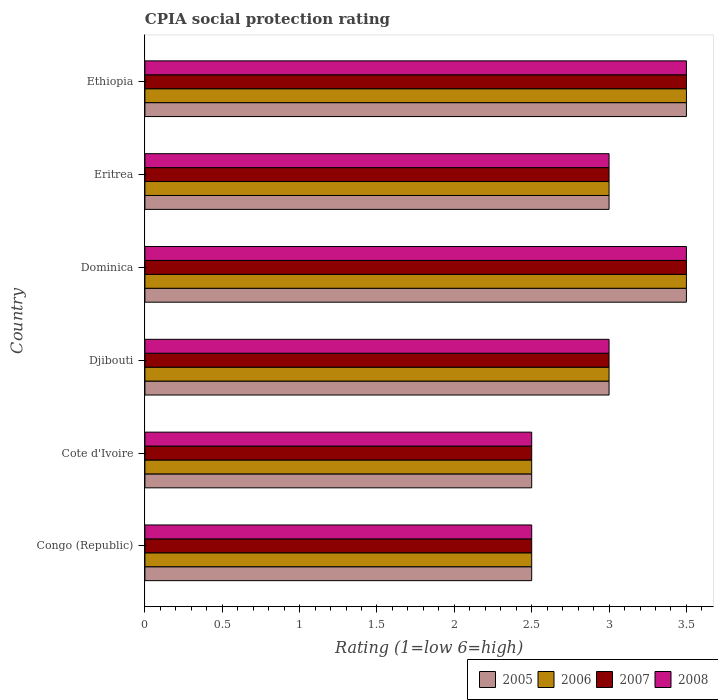How many groups of bars are there?
Your answer should be very brief. 6. How many bars are there on the 6th tick from the top?
Give a very brief answer. 4. What is the label of the 4th group of bars from the top?
Provide a succinct answer. Djibouti. In how many cases, is the number of bars for a given country not equal to the number of legend labels?
Provide a succinct answer. 0. What is the CPIA rating in 2005 in Congo (Republic)?
Make the answer very short. 2.5. Across all countries, what is the maximum CPIA rating in 2007?
Offer a terse response. 3.5. Across all countries, what is the minimum CPIA rating in 2006?
Offer a terse response. 2.5. In which country was the CPIA rating in 2007 maximum?
Ensure brevity in your answer.  Dominica. In which country was the CPIA rating in 2006 minimum?
Your answer should be very brief. Congo (Republic). What is the total CPIA rating in 2005 in the graph?
Provide a succinct answer. 18. What is the difference between the CPIA rating in 2007 in Cote d'Ivoire and that in Ethiopia?
Offer a very short reply. -1. In how many countries, is the CPIA rating in 2006 greater than 0.6 ?
Provide a succinct answer. 6. What is the ratio of the CPIA rating in 2005 in Congo (Republic) to that in Ethiopia?
Keep it short and to the point. 0.71. Is the CPIA rating in 2008 in Eritrea less than that in Ethiopia?
Your answer should be very brief. Yes. What is the difference between the highest and the second highest CPIA rating in 2005?
Ensure brevity in your answer.  0. What does the 4th bar from the top in Congo (Republic) represents?
Your response must be concise. 2005. Is it the case that in every country, the sum of the CPIA rating in 2008 and CPIA rating in 2005 is greater than the CPIA rating in 2007?
Your answer should be compact. Yes. How many bars are there?
Your answer should be very brief. 24. Are all the bars in the graph horizontal?
Your response must be concise. Yes. What is the difference between two consecutive major ticks on the X-axis?
Keep it short and to the point. 0.5. How many legend labels are there?
Your response must be concise. 4. How are the legend labels stacked?
Offer a very short reply. Horizontal. What is the title of the graph?
Provide a short and direct response. CPIA social protection rating. What is the Rating (1=low 6=high) of 2005 in Congo (Republic)?
Your answer should be very brief. 2.5. What is the Rating (1=low 6=high) in 2007 in Congo (Republic)?
Provide a short and direct response. 2.5. What is the Rating (1=low 6=high) in 2008 in Congo (Republic)?
Provide a short and direct response. 2.5. What is the Rating (1=low 6=high) of 2005 in Cote d'Ivoire?
Offer a very short reply. 2.5. What is the Rating (1=low 6=high) in 2008 in Cote d'Ivoire?
Ensure brevity in your answer.  2.5. What is the Rating (1=low 6=high) in 2006 in Djibouti?
Ensure brevity in your answer.  3. What is the Rating (1=low 6=high) in 2007 in Djibouti?
Make the answer very short. 3. What is the Rating (1=low 6=high) in 2006 in Dominica?
Offer a terse response. 3.5. What is the Rating (1=low 6=high) of 2007 in Dominica?
Make the answer very short. 3.5. What is the Rating (1=low 6=high) in 2008 in Dominica?
Your answer should be compact. 3.5. What is the Rating (1=low 6=high) in 2007 in Eritrea?
Provide a succinct answer. 3. What is the Rating (1=low 6=high) in 2006 in Ethiopia?
Ensure brevity in your answer.  3.5. What is the Rating (1=low 6=high) in 2008 in Ethiopia?
Provide a succinct answer. 3.5. Across all countries, what is the maximum Rating (1=low 6=high) of 2005?
Give a very brief answer. 3.5. Across all countries, what is the maximum Rating (1=low 6=high) in 2008?
Make the answer very short. 3.5. Across all countries, what is the minimum Rating (1=low 6=high) in 2006?
Provide a succinct answer. 2.5. What is the total Rating (1=low 6=high) of 2005 in the graph?
Keep it short and to the point. 18. What is the total Rating (1=low 6=high) of 2007 in the graph?
Your answer should be very brief. 18. What is the total Rating (1=low 6=high) in 2008 in the graph?
Make the answer very short. 18. What is the difference between the Rating (1=low 6=high) in 2005 in Congo (Republic) and that in Cote d'Ivoire?
Ensure brevity in your answer.  0. What is the difference between the Rating (1=low 6=high) in 2007 in Congo (Republic) and that in Djibouti?
Give a very brief answer. -0.5. What is the difference between the Rating (1=low 6=high) of 2008 in Congo (Republic) and that in Djibouti?
Keep it short and to the point. -0.5. What is the difference between the Rating (1=low 6=high) in 2005 in Congo (Republic) and that in Dominica?
Your answer should be very brief. -1. What is the difference between the Rating (1=low 6=high) in 2007 in Congo (Republic) and that in Dominica?
Ensure brevity in your answer.  -1. What is the difference between the Rating (1=low 6=high) of 2008 in Congo (Republic) and that in Eritrea?
Give a very brief answer. -0.5. What is the difference between the Rating (1=low 6=high) of 2005 in Congo (Republic) and that in Ethiopia?
Provide a succinct answer. -1. What is the difference between the Rating (1=low 6=high) of 2006 in Congo (Republic) and that in Ethiopia?
Keep it short and to the point. -1. What is the difference between the Rating (1=low 6=high) of 2005 in Cote d'Ivoire and that in Djibouti?
Provide a short and direct response. -0.5. What is the difference between the Rating (1=low 6=high) of 2006 in Cote d'Ivoire and that in Djibouti?
Keep it short and to the point. -0.5. What is the difference between the Rating (1=low 6=high) of 2007 in Cote d'Ivoire and that in Djibouti?
Your answer should be compact. -0.5. What is the difference between the Rating (1=low 6=high) in 2008 in Cote d'Ivoire and that in Djibouti?
Make the answer very short. -0.5. What is the difference between the Rating (1=low 6=high) in 2005 in Cote d'Ivoire and that in Dominica?
Keep it short and to the point. -1. What is the difference between the Rating (1=low 6=high) of 2006 in Cote d'Ivoire and that in Dominica?
Provide a succinct answer. -1. What is the difference between the Rating (1=low 6=high) of 2008 in Cote d'Ivoire and that in Dominica?
Give a very brief answer. -1. What is the difference between the Rating (1=low 6=high) in 2006 in Cote d'Ivoire and that in Eritrea?
Offer a terse response. -0.5. What is the difference between the Rating (1=low 6=high) in 2007 in Cote d'Ivoire and that in Eritrea?
Your response must be concise. -0.5. What is the difference between the Rating (1=low 6=high) of 2008 in Cote d'Ivoire and that in Eritrea?
Offer a terse response. -0.5. What is the difference between the Rating (1=low 6=high) of 2008 in Cote d'Ivoire and that in Ethiopia?
Provide a short and direct response. -1. What is the difference between the Rating (1=low 6=high) of 2006 in Djibouti and that in Dominica?
Ensure brevity in your answer.  -0.5. What is the difference between the Rating (1=low 6=high) of 2005 in Djibouti and that in Eritrea?
Your response must be concise. 0. What is the difference between the Rating (1=low 6=high) in 2008 in Djibouti and that in Eritrea?
Provide a succinct answer. 0. What is the difference between the Rating (1=low 6=high) in 2005 in Djibouti and that in Ethiopia?
Give a very brief answer. -0.5. What is the difference between the Rating (1=low 6=high) in 2006 in Djibouti and that in Ethiopia?
Offer a very short reply. -0.5. What is the difference between the Rating (1=low 6=high) in 2008 in Djibouti and that in Ethiopia?
Keep it short and to the point. -0.5. What is the difference between the Rating (1=low 6=high) in 2006 in Dominica and that in Eritrea?
Make the answer very short. 0.5. What is the difference between the Rating (1=low 6=high) of 2008 in Dominica and that in Eritrea?
Provide a short and direct response. 0.5. What is the difference between the Rating (1=low 6=high) in 2005 in Dominica and that in Ethiopia?
Your answer should be compact. 0. What is the difference between the Rating (1=low 6=high) in 2007 in Dominica and that in Ethiopia?
Offer a very short reply. 0. What is the difference between the Rating (1=low 6=high) in 2008 in Eritrea and that in Ethiopia?
Provide a succinct answer. -0.5. What is the difference between the Rating (1=low 6=high) in 2007 in Congo (Republic) and the Rating (1=low 6=high) in 2008 in Cote d'Ivoire?
Give a very brief answer. 0. What is the difference between the Rating (1=low 6=high) in 2005 in Congo (Republic) and the Rating (1=low 6=high) in 2006 in Djibouti?
Give a very brief answer. -0.5. What is the difference between the Rating (1=low 6=high) in 2005 in Congo (Republic) and the Rating (1=low 6=high) in 2007 in Djibouti?
Your answer should be compact. -0.5. What is the difference between the Rating (1=low 6=high) of 2007 in Congo (Republic) and the Rating (1=low 6=high) of 2008 in Djibouti?
Provide a short and direct response. -0.5. What is the difference between the Rating (1=low 6=high) in 2005 in Congo (Republic) and the Rating (1=low 6=high) in 2007 in Dominica?
Provide a succinct answer. -1. What is the difference between the Rating (1=low 6=high) in 2007 in Congo (Republic) and the Rating (1=low 6=high) in 2008 in Dominica?
Your answer should be very brief. -1. What is the difference between the Rating (1=low 6=high) in 2005 in Congo (Republic) and the Rating (1=low 6=high) in 2006 in Eritrea?
Your answer should be very brief. -0.5. What is the difference between the Rating (1=low 6=high) of 2005 in Congo (Republic) and the Rating (1=low 6=high) of 2007 in Eritrea?
Your answer should be very brief. -0.5. What is the difference between the Rating (1=low 6=high) of 2006 in Congo (Republic) and the Rating (1=low 6=high) of 2007 in Eritrea?
Offer a very short reply. -0.5. What is the difference between the Rating (1=low 6=high) in 2006 in Congo (Republic) and the Rating (1=low 6=high) in 2008 in Eritrea?
Keep it short and to the point. -0.5. What is the difference between the Rating (1=low 6=high) of 2005 in Congo (Republic) and the Rating (1=low 6=high) of 2006 in Ethiopia?
Provide a succinct answer. -1. What is the difference between the Rating (1=low 6=high) in 2006 in Congo (Republic) and the Rating (1=low 6=high) in 2007 in Ethiopia?
Your answer should be very brief. -1. What is the difference between the Rating (1=low 6=high) in 2006 in Congo (Republic) and the Rating (1=low 6=high) in 2008 in Ethiopia?
Offer a very short reply. -1. What is the difference between the Rating (1=low 6=high) of 2005 in Cote d'Ivoire and the Rating (1=low 6=high) of 2007 in Djibouti?
Give a very brief answer. -0.5. What is the difference between the Rating (1=low 6=high) in 2006 in Cote d'Ivoire and the Rating (1=low 6=high) in 2007 in Djibouti?
Your answer should be compact. -0.5. What is the difference between the Rating (1=low 6=high) in 2005 in Cote d'Ivoire and the Rating (1=low 6=high) in 2006 in Dominica?
Keep it short and to the point. -1. What is the difference between the Rating (1=low 6=high) in 2005 in Cote d'Ivoire and the Rating (1=low 6=high) in 2007 in Dominica?
Your answer should be compact. -1. What is the difference between the Rating (1=low 6=high) in 2005 in Cote d'Ivoire and the Rating (1=low 6=high) in 2008 in Dominica?
Provide a succinct answer. -1. What is the difference between the Rating (1=low 6=high) of 2006 in Cote d'Ivoire and the Rating (1=low 6=high) of 2008 in Dominica?
Make the answer very short. -1. What is the difference between the Rating (1=low 6=high) of 2007 in Cote d'Ivoire and the Rating (1=low 6=high) of 2008 in Dominica?
Offer a terse response. -1. What is the difference between the Rating (1=low 6=high) of 2005 in Cote d'Ivoire and the Rating (1=low 6=high) of 2006 in Eritrea?
Keep it short and to the point. -0.5. What is the difference between the Rating (1=low 6=high) in 2005 in Cote d'Ivoire and the Rating (1=low 6=high) in 2007 in Eritrea?
Keep it short and to the point. -0.5. What is the difference between the Rating (1=low 6=high) of 2005 in Cote d'Ivoire and the Rating (1=low 6=high) of 2008 in Eritrea?
Your answer should be very brief. -0.5. What is the difference between the Rating (1=low 6=high) of 2006 in Cote d'Ivoire and the Rating (1=low 6=high) of 2007 in Eritrea?
Your answer should be compact. -0.5. What is the difference between the Rating (1=low 6=high) of 2005 in Cote d'Ivoire and the Rating (1=low 6=high) of 2008 in Ethiopia?
Ensure brevity in your answer.  -1. What is the difference between the Rating (1=low 6=high) of 2006 in Cote d'Ivoire and the Rating (1=low 6=high) of 2007 in Ethiopia?
Your answer should be very brief. -1. What is the difference between the Rating (1=low 6=high) of 2007 in Cote d'Ivoire and the Rating (1=low 6=high) of 2008 in Ethiopia?
Provide a succinct answer. -1. What is the difference between the Rating (1=low 6=high) in 2005 in Djibouti and the Rating (1=low 6=high) in 2007 in Dominica?
Keep it short and to the point. -0.5. What is the difference between the Rating (1=low 6=high) in 2005 in Djibouti and the Rating (1=low 6=high) in 2008 in Dominica?
Ensure brevity in your answer.  -0.5. What is the difference between the Rating (1=low 6=high) of 2006 in Djibouti and the Rating (1=low 6=high) of 2008 in Dominica?
Offer a very short reply. -0.5. What is the difference between the Rating (1=low 6=high) of 2006 in Djibouti and the Rating (1=low 6=high) of 2007 in Eritrea?
Ensure brevity in your answer.  0. What is the difference between the Rating (1=low 6=high) in 2006 in Djibouti and the Rating (1=low 6=high) in 2008 in Eritrea?
Make the answer very short. 0. What is the difference between the Rating (1=low 6=high) of 2006 in Djibouti and the Rating (1=low 6=high) of 2007 in Ethiopia?
Keep it short and to the point. -0.5. What is the difference between the Rating (1=low 6=high) of 2006 in Djibouti and the Rating (1=low 6=high) of 2008 in Ethiopia?
Provide a short and direct response. -0.5. What is the difference between the Rating (1=low 6=high) in 2005 in Dominica and the Rating (1=low 6=high) in 2006 in Eritrea?
Provide a short and direct response. 0.5. What is the difference between the Rating (1=low 6=high) of 2005 in Dominica and the Rating (1=low 6=high) of 2007 in Eritrea?
Your response must be concise. 0.5. What is the difference between the Rating (1=low 6=high) in 2006 in Dominica and the Rating (1=low 6=high) in 2008 in Eritrea?
Ensure brevity in your answer.  0.5. What is the difference between the Rating (1=low 6=high) of 2005 in Dominica and the Rating (1=low 6=high) of 2008 in Ethiopia?
Offer a terse response. 0. What is the difference between the Rating (1=low 6=high) of 2006 in Dominica and the Rating (1=low 6=high) of 2007 in Ethiopia?
Give a very brief answer. 0. What is the difference between the Rating (1=low 6=high) in 2006 in Eritrea and the Rating (1=low 6=high) in 2007 in Ethiopia?
Provide a short and direct response. -0.5. What is the average Rating (1=low 6=high) of 2005 per country?
Keep it short and to the point. 3. What is the average Rating (1=low 6=high) in 2006 per country?
Your answer should be very brief. 3. What is the average Rating (1=low 6=high) in 2007 per country?
Your answer should be very brief. 3. What is the difference between the Rating (1=low 6=high) in 2007 and Rating (1=low 6=high) in 2008 in Congo (Republic)?
Offer a very short reply. 0. What is the difference between the Rating (1=low 6=high) in 2005 and Rating (1=low 6=high) in 2006 in Cote d'Ivoire?
Offer a very short reply. 0. What is the difference between the Rating (1=low 6=high) in 2007 and Rating (1=low 6=high) in 2008 in Cote d'Ivoire?
Offer a very short reply. 0. What is the difference between the Rating (1=low 6=high) in 2006 and Rating (1=low 6=high) in 2007 in Djibouti?
Offer a very short reply. 0. What is the difference between the Rating (1=low 6=high) of 2006 and Rating (1=low 6=high) of 2008 in Djibouti?
Ensure brevity in your answer.  0. What is the difference between the Rating (1=low 6=high) in 2005 and Rating (1=low 6=high) in 2008 in Dominica?
Your response must be concise. 0. What is the difference between the Rating (1=low 6=high) of 2006 and Rating (1=low 6=high) of 2007 in Dominica?
Offer a very short reply. 0. What is the difference between the Rating (1=low 6=high) of 2006 and Rating (1=low 6=high) of 2008 in Dominica?
Provide a succinct answer. 0. What is the difference between the Rating (1=low 6=high) in 2005 and Rating (1=low 6=high) in 2006 in Eritrea?
Provide a succinct answer. 0. What is the difference between the Rating (1=low 6=high) of 2005 and Rating (1=low 6=high) of 2008 in Ethiopia?
Your answer should be very brief. 0. What is the difference between the Rating (1=low 6=high) of 2006 and Rating (1=low 6=high) of 2007 in Ethiopia?
Provide a succinct answer. 0. What is the difference between the Rating (1=low 6=high) in 2006 and Rating (1=low 6=high) in 2008 in Ethiopia?
Offer a terse response. 0. What is the ratio of the Rating (1=low 6=high) of 2005 in Congo (Republic) to that in Cote d'Ivoire?
Your answer should be very brief. 1. What is the ratio of the Rating (1=low 6=high) in 2006 in Congo (Republic) to that in Cote d'Ivoire?
Keep it short and to the point. 1. What is the ratio of the Rating (1=low 6=high) in 2007 in Congo (Republic) to that in Cote d'Ivoire?
Your response must be concise. 1. What is the ratio of the Rating (1=low 6=high) of 2005 in Congo (Republic) to that in Djibouti?
Your response must be concise. 0.83. What is the ratio of the Rating (1=low 6=high) in 2006 in Congo (Republic) to that in Djibouti?
Give a very brief answer. 0.83. What is the ratio of the Rating (1=low 6=high) of 2008 in Congo (Republic) to that in Djibouti?
Offer a very short reply. 0.83. What is the ratio of the Rating (1=low 6=high) in 2005 in Congo (Republic) to that in Dominica?
Give a very brief answer. 0.71. What is the ratio of the Rating (1=low 6=high) in 2008 in Congo (Republic) to that in Dominica?
Your response must be concise. 0.71. What is the ratio of the Rating (1=low 6=high) in 2005 in Congo (Republic) to that in Eritrea?
Give a very brief answer. 0.83. What is the ratio of the Rating (1=low 6=high) in 2006 in Congo (Republic) to that in Eritrea?
Offer a very short reply. 0.83. What is the ratio of the Rating (1=low 6=high) of 2007 in Congo (Republic) to that in Eritrea?
Your answer should be compact. 0.83. What is the ratio of the Rating (1=low 6=high) in 2005 in Congo (Republic) to that in Ethiopia?
Your answer should be very brief. 0.71. What is the ratio of the Rating (1=low 6=high) of 2007 in Congo (Republic) to that in Ethiopia?
Your response must be concise. 0.71. What is the ratio of the Rating (1=low 6=high) in 2008 in Congo (Republic) to that in Ethiopia?
Offer a terse response. 0.71. What is the ratio of the Rating (1=low 6=high) in 2008 in Cote d'Ivoire to that in Djibouti?
Give a very brief answer. 0.83. What is the ratio of the Rating (1=low 6=high) of 2005 in Cote d'Ivoire to that in Dominica?
Keep it short and to the point. 0.71. What is the ratio of the Rating (1=low 6=high) in 2007 in Cote d'Ivoire to that in Dominica?
Your response must be concise. 0.71. What is the ratio of the Rating (1=low 6=high) in 2005 in Cote d'Ivoire to that in Ethiopia?
Give a very brief answer. 0.71. What is the ratio of the Rating (1=low 6=high) in 2007 in Cote d'Ivoire to that in Ethiopia?
Your answer should be very brief. 0.71. What is the ratio of the Rating (1=low 6=high) in 2005 in Djibouti to that in Eritrea?
Your answer should be compact. 1. What is the ratio of the Rating (1=low 6=high) in 2006 in Djibouti to that in Eritrea?
Provide a succinct answer. 1. What is the ratio of the Rating (1=low 6=high) of 2007 in Djibouti to that in Eritrea?
Offer a terse response. 1. What is the ratio of the Rating (1=low 6=high) in 2008 in Djibouti to that in Eritrea?
Offer a terse response. 1. What is the ratio of the Rating (1=low 6=high) of 2007 in Djibouti to that in Ethiopia?
Provide a succinct answer. 0.86. What is the ratio of the Rating (1=low 6=high) of 2005 in Dominica to that in Eritrea?
Offer a very short reply. 1.17. What is the ratio of the Rating (1=low 6=high) in 2006 in Dominica to that in Eritrea?
Offer a terse response. 1.17. What is the ratio of the Rating (1=low 6=high) in 2005 in Dominica to that in Ethiopia?
Your response must be concise. 1. What is the ratio of the Rating (1=low 6=high) in 2007 in Dominica to that in Ethiopia?
Provide a succinct answer. 1. What is the ratio of the Rating (1=low 6=high) in 2008 in Dominica to that in Ethiopia?
Ensure brevity in your answer.  1. What is the ratio of the Rating (1=low 6=high) in 2005 in Eritrea to that in Ethiopia?
Your response must be concise. 0.86. What is the ratio of the Rating (1=low 6=high) in 2006 in Eritrea to that in Ethiopia?
Make the answer very short. 0.86. What is the ratio of the Rating (1=low 6=high) of 2007 in Eritrea to that in Ethiopia?
Offer a terse response. 0.86. What is the difference between the highest and the second highest Rating (1=low 6=high) in 2005?
Provide a succinct answer. 0. What is the difference between the highest and the second highest Rating (1=low 6=high) in 2006?
Provide a short and direct response. 0. What is the difference between the highest and the second highest Rating (1=low 6=high) of 2007?
Offer a terse response. 0. What is the difference between the highest and the lowest Rating (1=low 6=high) of 2005?
Offer a terse response. 1. What is the difference between the highest and the lowest Rating (1=low 6=high) of 2007?
Provide a succinct answer. 1. 